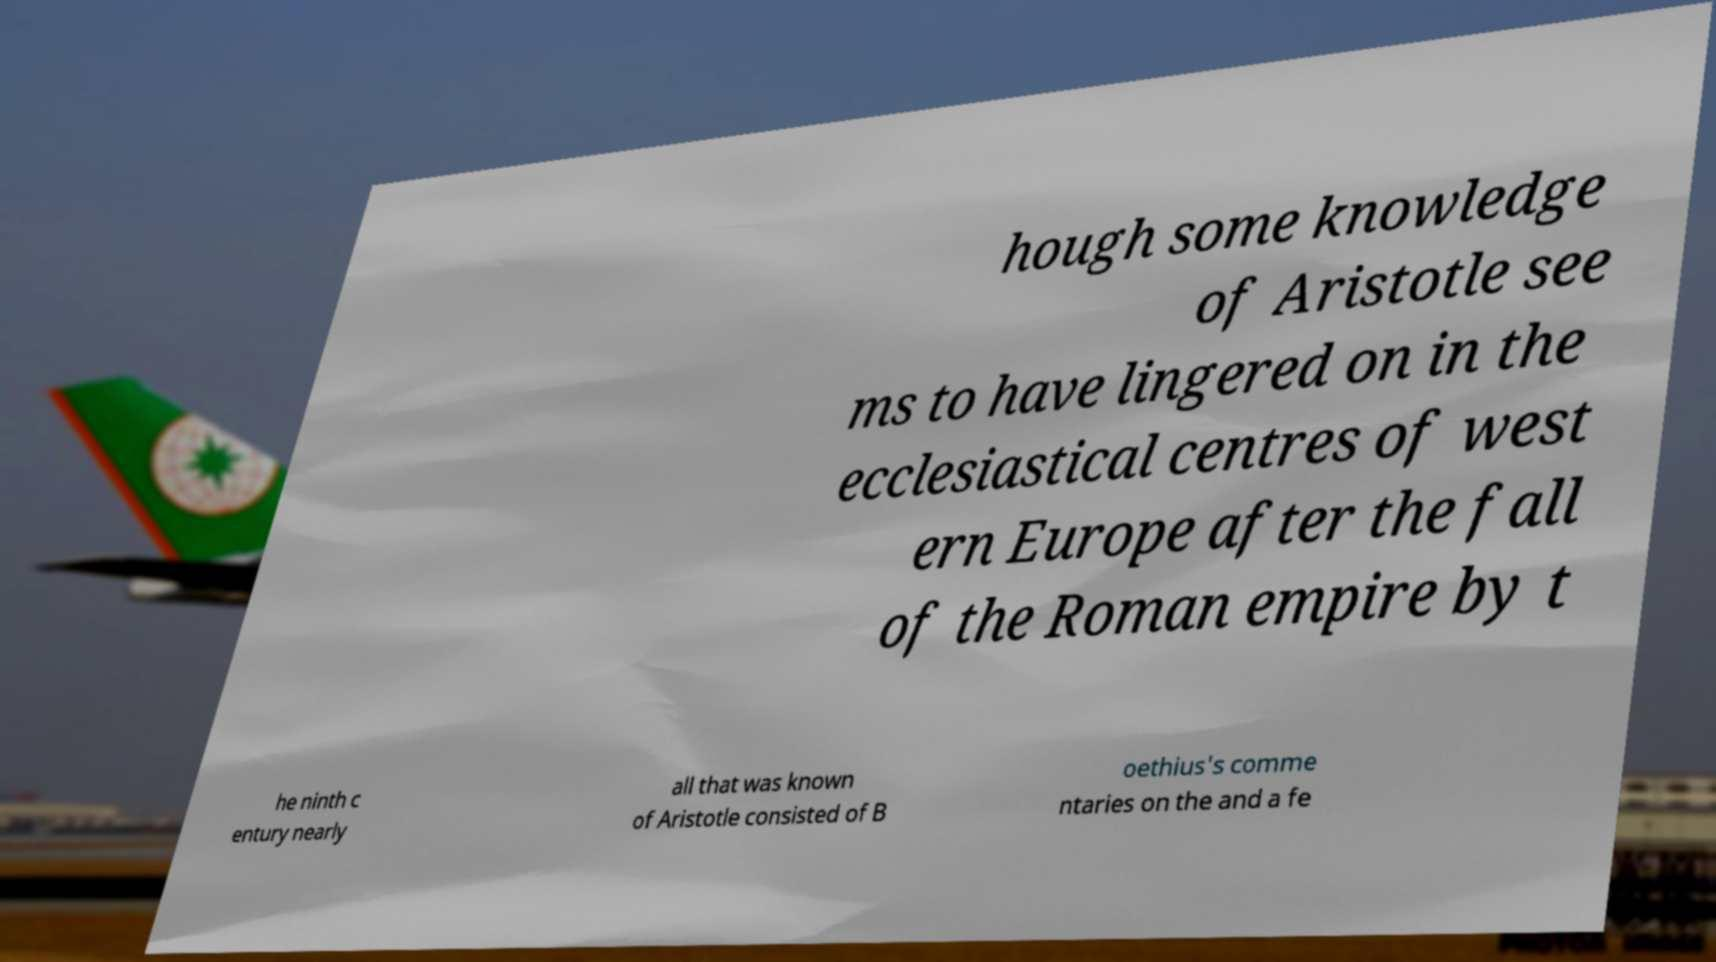I need the written content from this picture converted into text. Can you do that? hough some knowledge of Aristotle see ms to have lingered on in the ecclesiastical centres of west ern Europe after the fall of the Roman empire by t he ninth c entury nearly all that was known of Aristotle consisted of B oethius's comme ntaries on the and a fe 